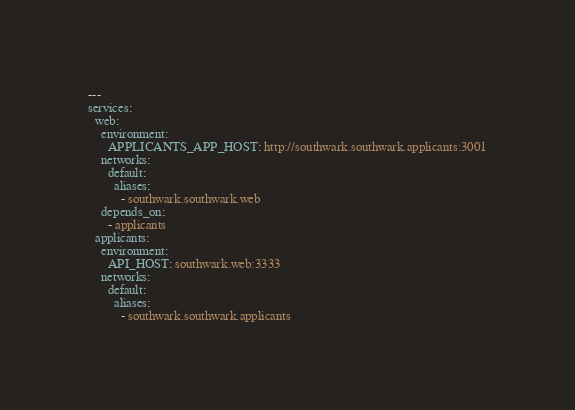Convert code to text. <code><loc_0><loc_0><loc_500><loc_500><_YAML_>---
services:
  web:
    environment:
      APPLICANTS_APP_HOST: http://southwark.southwark.applicants:3001
    networks:
      default:
        aliases:
          - southwark.southwark.web
    depends_on:
      - applicants
  applicants:
    environment:
      API_HOST: southwark.web:3333
    networks:
      default:
        aliases:
          - southwark.southwark.applicants
</code> 